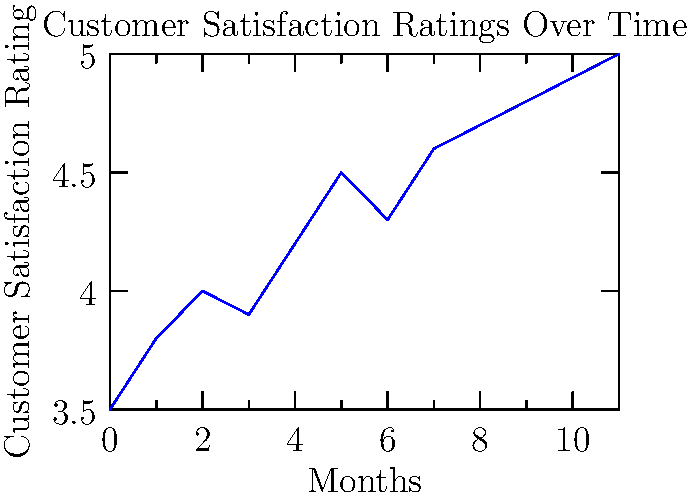Based on the line graph showing customer satisfaction ratings over a 12-month period, what strategy would you recommend to maintain the positive trend observed in the latter half of the year? To answer this question, let's analyze the graph step-by-step:

1. Observe the overall trend: The graph shows a general upward trend in customer satisfaction ratings over the 12-month period.

2. Identify key periods:
   a. Months 0-5: Steady increase from 3.5 to 4.5
   b. Months 5-6: Slight decrease from 4.5 to 4.3
   c. Months 6-11: Consistent increase from 4.3 to 5.0

3. Focus on the latter half (months 6-11):
   - This period shows the most consistent and significant improvement
   - Ratings increased from 4.3 to 5.0, reaching the maximum possible score

4. Consider the persona of a customer service manager who values patience and empathy:
   - The consistent improvement in the latter half likely results from implemented strategies focusing on these values

5. Develop a strategy to maintain the positive trend:
   - Continue emphasizing patience and empathy in customer interactions
   - Analyze what specific actions or changes were made around month 6 that led to the consistent improvement
   - Implement regular training sessions to reinforce these successful practices
   - Use customer feedback to identify areas where patience and empathy had the most significant impact

6. Recommendation:
   Maintain and enhance the focus on patience and empathy in customer service interactions, while continuously gathering and analyzing customer feedback to refine approaches and identify new opportunities for improvement.
Answer: Continue emphasizing patience and empathy, analyze successful practices, implement regular training, and use customer feedback for continuous improvement. 